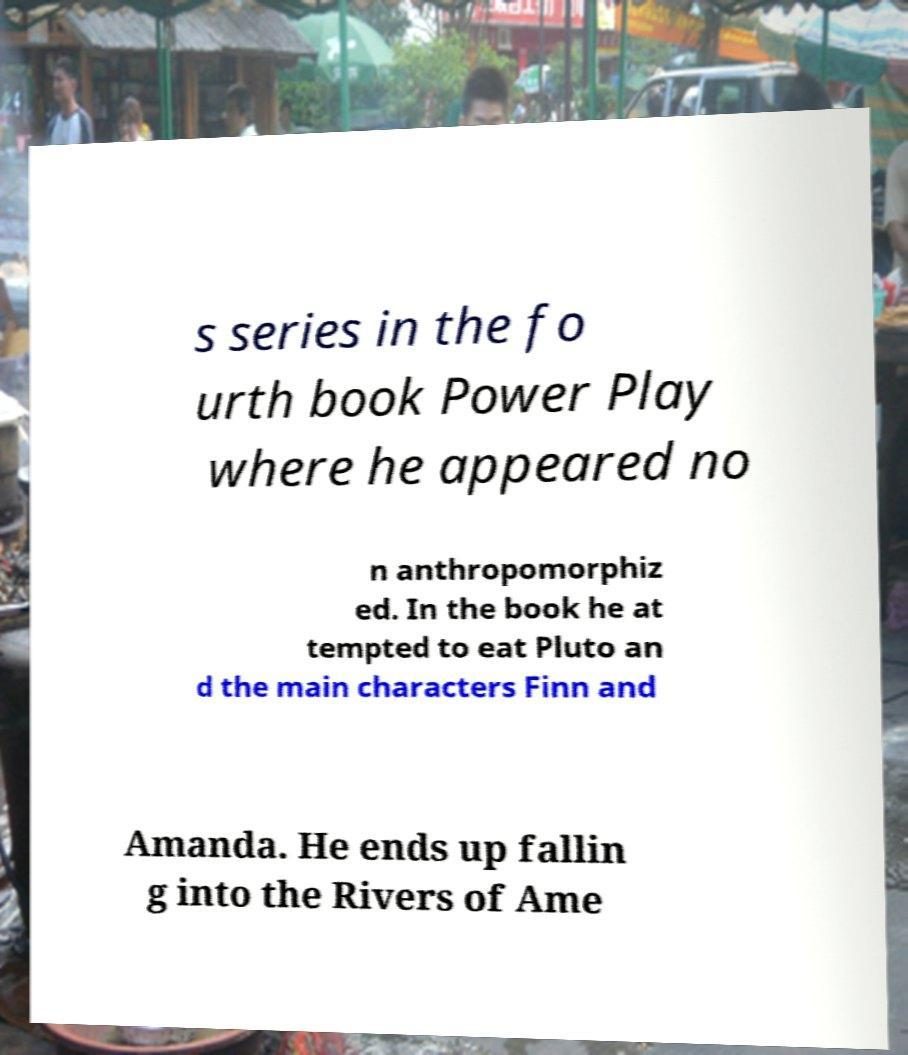I need the written content from this picture converted into text. Can you do that? s series in the fo urth book Power Play where he appeared no n anthropomorphiz ed. In the book he at tempted to eat Pluto an d the main characters Finn and Amanda. He ends up fallin g into the Rivers of Ame 